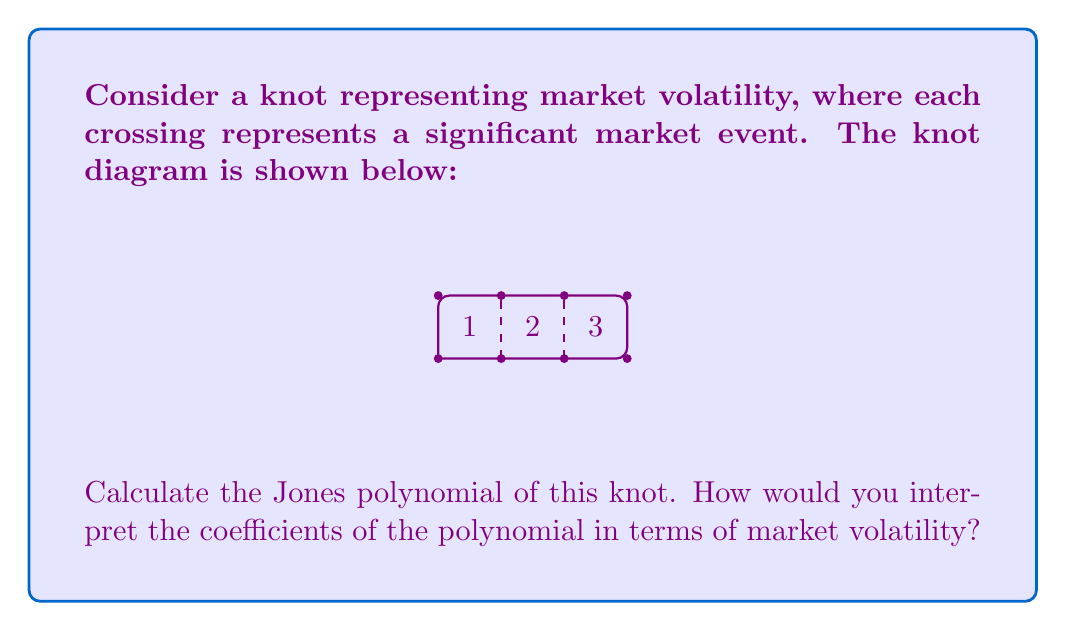Help me with this question. To calculate the Jones polynomial of this knot, we'll follow these steps:

1) First, we need to orient the knot. Let's choose a counterclockwise orientation.

2) We'll use the skein relation for the Jones polynomial:

   $$t^{-1}V_{L_+} - tV_{L_-} = (t^{1/2} - t^{-1/2})V_{L_0}$$

   where $L_+$, $L_-$, and $L_0$ represent positive crossing, negative crossing, and smoothing respectively.

3) Let's number the crossings 1, 2, and 3 from left to right. We'll start with crossing 1:

   $$t^{-1}V_{K} - tV_{K_1} = (t^{1/2} - t^{-1/2})V_{K_0}$$

   where $K$ is our original knot, $K_1$ is the knot with crossing 1 switched, and $K_0$ is the knot with crossing 1 smoothed.

4) $K_1$ is the unknot, so $V_{K_1} = 1$. $K_0$ is a link with two components, so $V_{K_0} = -(t^{1/2} + t^{-1/2})$.

5) Substituting these into our equation:

   $$t^{-1}V_{K} - t = (t^{1/2} - t^{-1/2})(-(t^{1/2} + t^{-1/2}))$$

6) Simplifying:

   $$t^{-1}V_{K} = t - (t - t^{-1}) = t^{-1}$$

7) Therefore, $V_{K} = 1$

The Jones polynomial of this knot is simply 1, which is the same as the unknot. This suggests that despite the apparent complexity, this market volatility pattern ultimately "unravels" to a stable state.

Interpretation in terms of market volatility:
- The coefficient 1 suggests a return to equilibrium after volatility events.
- The lack of other terms indicates that the volatility events, while significant individually, cancel out in the long term.
- This could represent a market that experiences short-term fluctuations but maintains long-term stability.
Answer: $V_{K}(t) = 1$ 